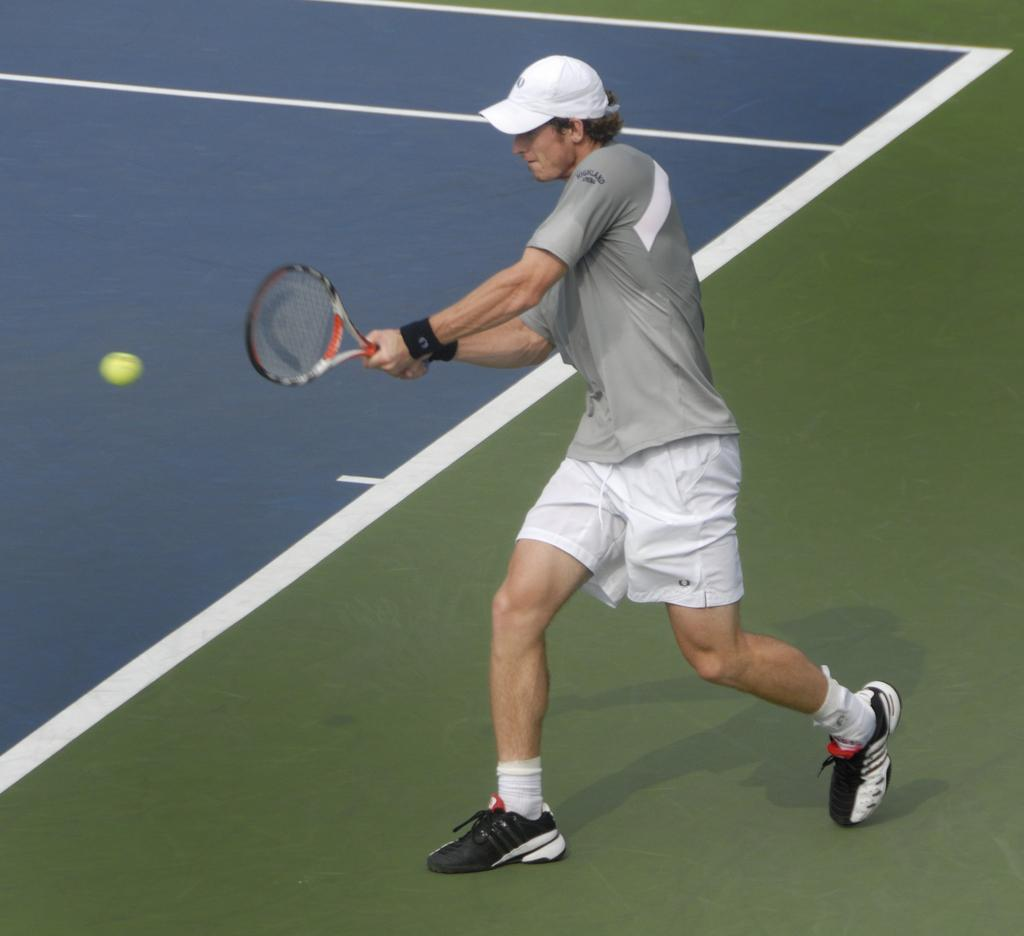Who or what is present in the image? There is a person in the image. What is the person wearing on their head? The person is wearing a cap. What object is the person holding in the image? The person is holding a tennis racket. Can you describe the object on the left side of the image? There is a ball on the left side of the image. How many frogs can be seen in the image? There are no frogs present in the image. What year is depicted in the image? The image does not depict a specific year; it is a snapshot of a person holding a tennis racket and wearing a cap. 